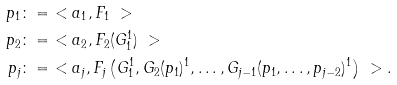Convert formula to latex. <formula><loc_0><loc_0><loc_500><loc_500>p _ { 1 } & \colon = \ < a _ { 1 } , F _ { 1 } \ > \\ p _ { 2 } & \colon = \ < a _ { 2 } , F _ { 2 } ( G _ { 1 } ^ { 1 } ) \ > \\ p _ { j } & \colon = \ < a _ { j } , F _ { j } \left ( G _ { 1 } ^ { 1 } , G _ { 2 } ( p _ { 1 } ) ^ { 1 } , \dots , G _ { j - 1 } ( p _ { 1 } , \dots , p _ { j - 2 } ) ^ { 1 } \right ) \ > .</formula> 